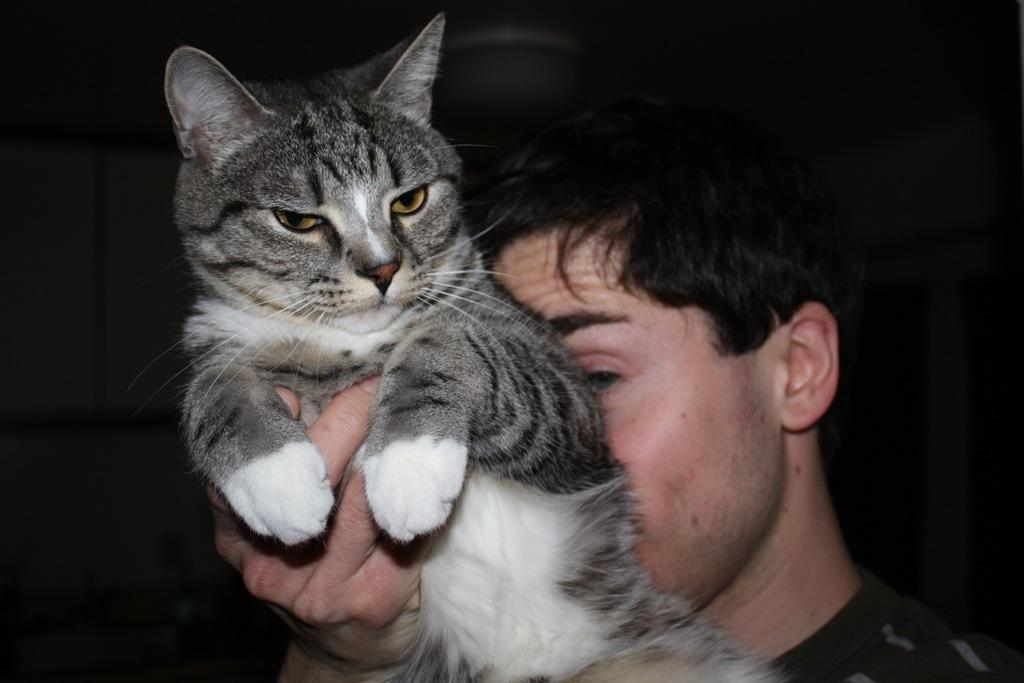What is the main subject of the image? The main subject of the image is a man. What is the man holding in his hand? The man is holding a cat in his hand. What can be observed about the background of the image? The background of the image is dark. What grade of stew is being served in the image? There is no stew present in the image, so it cannot be determined what grade of stew might be served. 